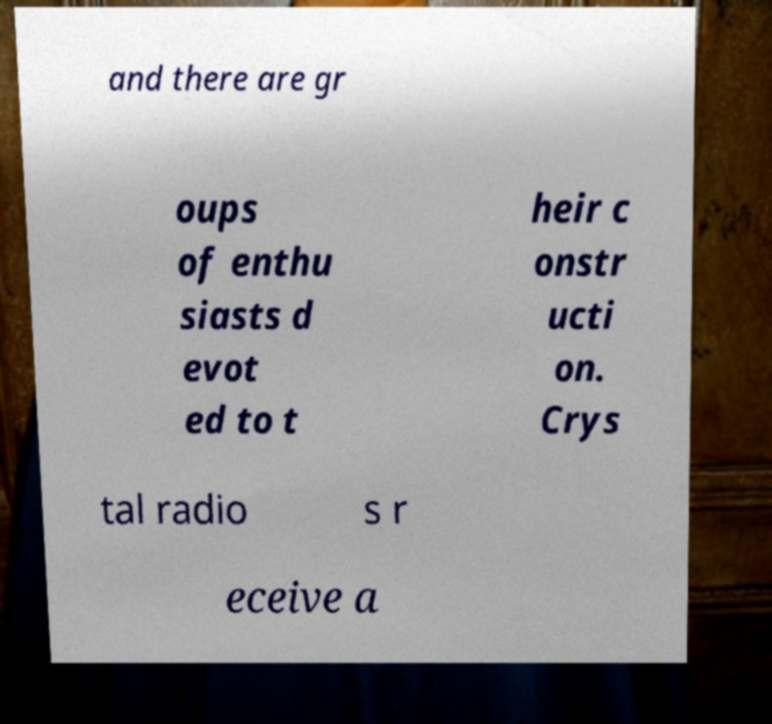Please read and relay the text visible in this image. What does it say? and there are gr oups of enthu siasts d evot ed to t heir c onstr ucti on. Crys tal radio s r eceive a 